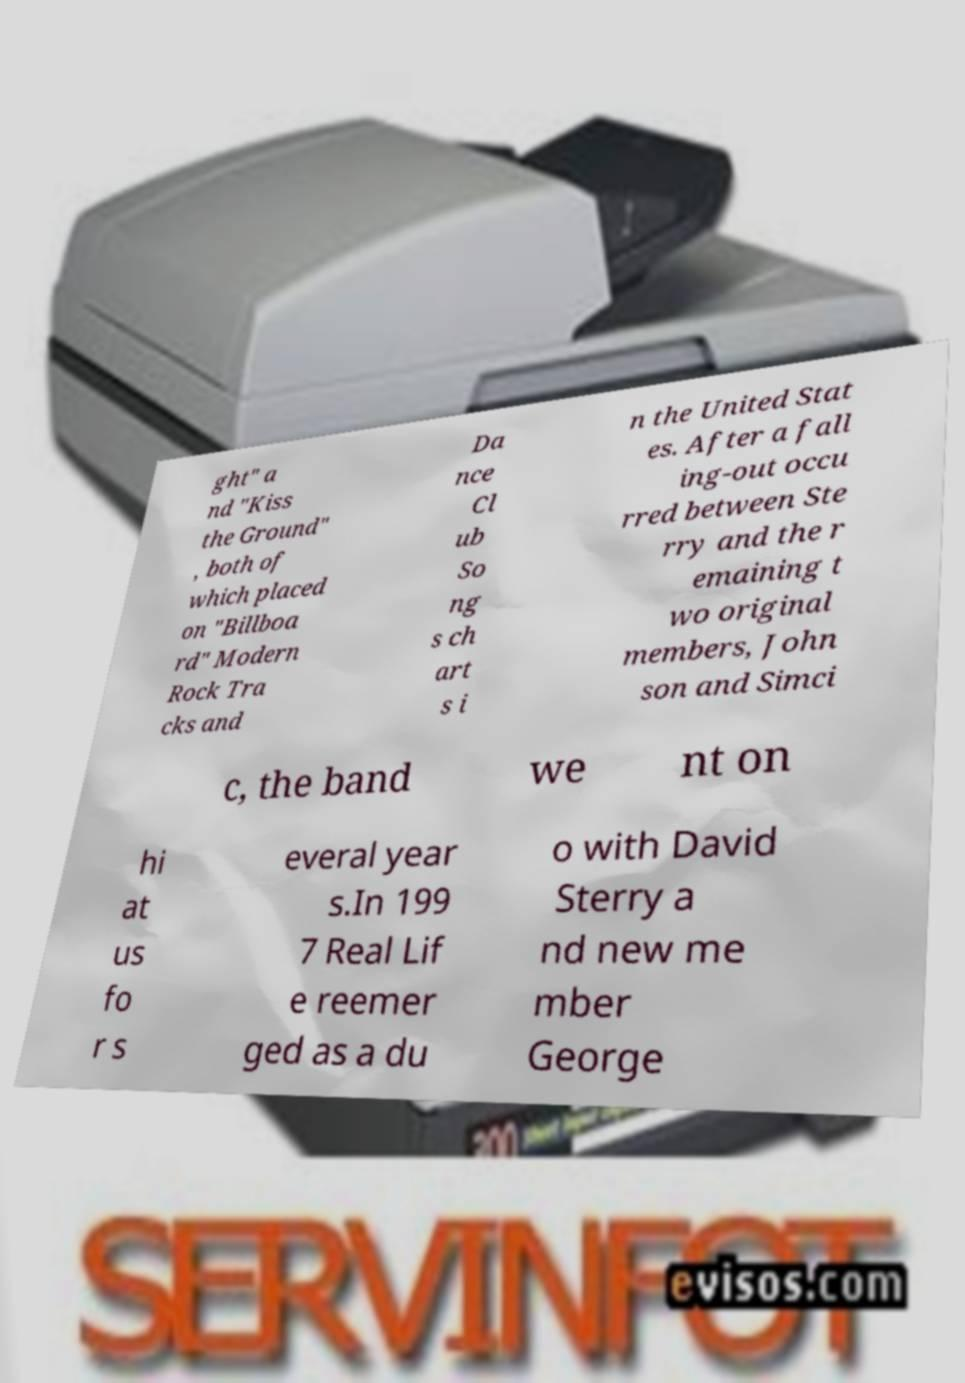Please read and relay the text visible in this image. What does it say? ght" a nd "Kiss the Ground" , both of which placed on "Billboa rd" Modern Rock Tra cks and Da nce Cl ub So ng s ch art s i n the United Stat es. After a fall ing-out occu rred between Ste rry and the r emaining t wo original members, John son and Simci c, the band we nt on hi at us fo r s everal year s.In 199 7 Real Lif e reemer ged as a du o with David Sterry a nd new me mber George 